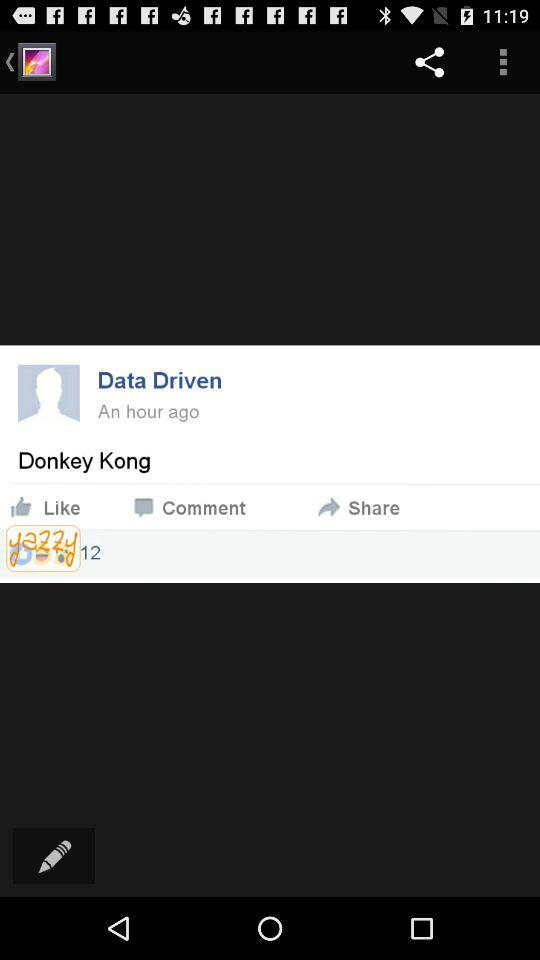How many hours ago was the post posted? The post was posted an hour ago. 